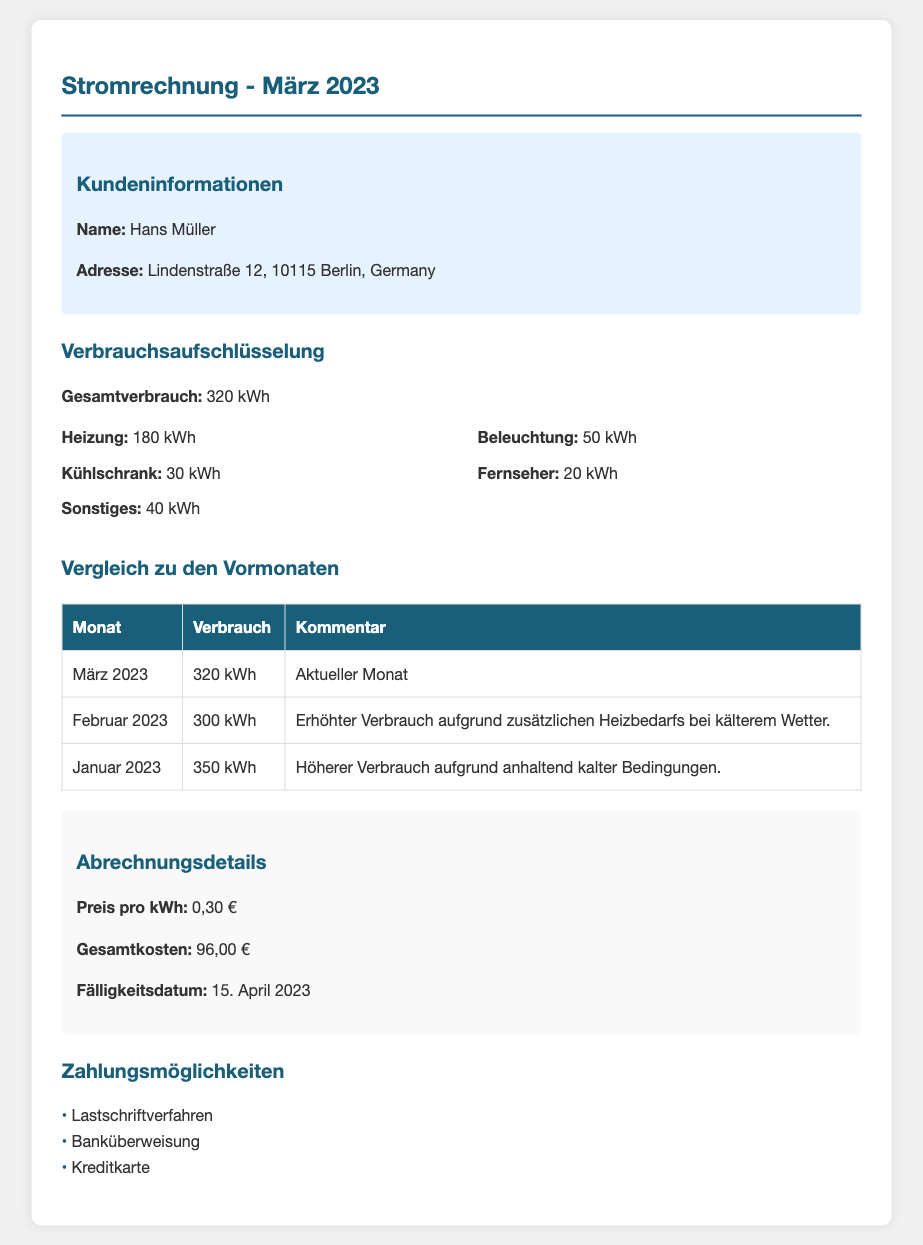Was ist der Gesamtverbrauch? Der Gesamtverbrauch ist der summierte Energieverbrauch für den Monat März 2023, der im Dokument angegeben ist.
Answer: 320 kWh Wie hoch sind die Gesamtkosten? Die Gesamtkosten werden in der Abrechnungsdetails-Sektion aufgeführt, basierend auf dem Preis pro kWh und dem Gesamtverbrauch.
Answer: 96,00 € Wann ist das Fälligkeitsdatum? Das Fälligkeitsdatum ist das Datum, bis zu dem die Zahlung geleistet werden muss, wie in der Abrechnungsdetails-Sektion angegeben.
Answer: 15. April 2023 Wie viel hat die Heizung verbraucht? Der Heizungsverbrauch wird als spezifischer Posten in der Verbrauchsaufschlüsselung angegeben.
Answer: 180 kWh Welcher Monat hatte den höchsten Verbrauch? Um den höchsten Verbrauch zu ermitteln, werden die Verbrauchswerte der Monate verglichen, die in der Vergleichstabelle angegeben sind.
Answer: Januar 2023 Was ist der Preis pro kWh? Der Preis pro kWh ist der festgelegte Preis, der in der Abrechnungsdetails-Sektion vermerkt ist.
Answer: 0,30 € Wie viel kWh hat der Kühlschrank verbraucht? Der Verbrauch des Kühlschranks ist ein spezifischer Posten in der Verbrauchsaufschlüsselung.
Answer: 30 kWh Welches Zahlungsmethoden sind verfügbar? Die Zahlungsmethoden sind die Optionen, die für die Begleichung der Rechnung zur Verfügung stehen, aufgelistet im Dokument.
Answer: Lastschriftverfahren, Banküberweisung, Kreditkarte Was war der Grund für den erhöhten Verbrauch im Februar? Der Grund für den erhöhten Verbrauch ist in der Vergleichstabelle für Februar 2023 angegeben.
Answer: Zusätzlichen Heizbedarfs bei kälterem Wetter 